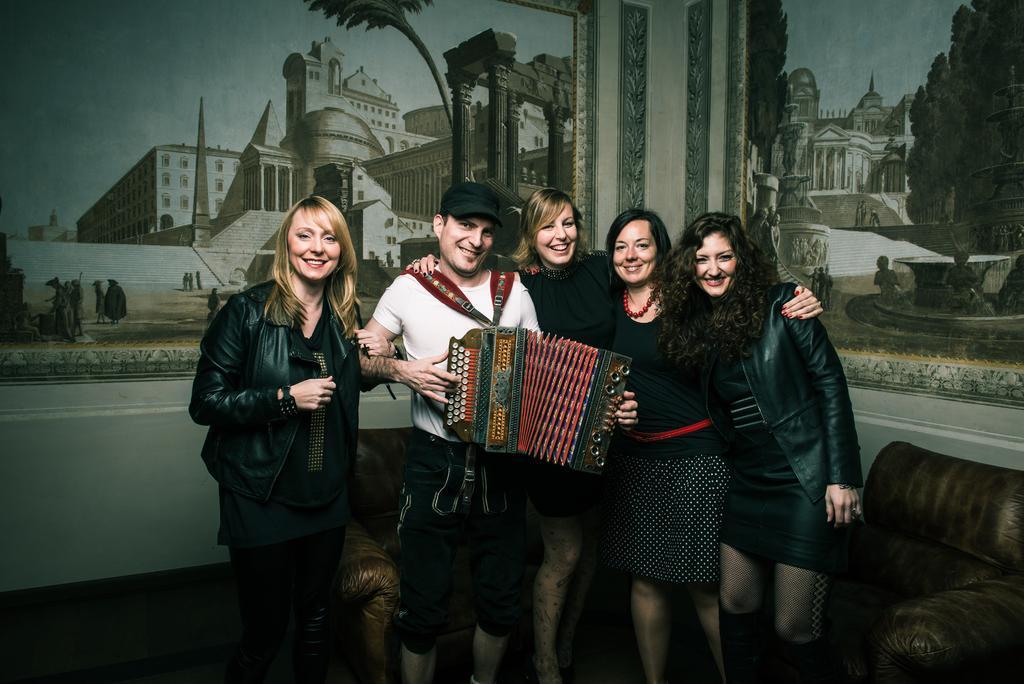Describe this image in one or two sentences. In this image I can see four women wearing black dresses and a man wearing white t shirt, black short and black cap are standing. I can see the man is holding a musical instrument in his hand. In the background I can see a couch, the white colored wall and few paintings in which I can see few buildings, few trees, few persons and the sky. 